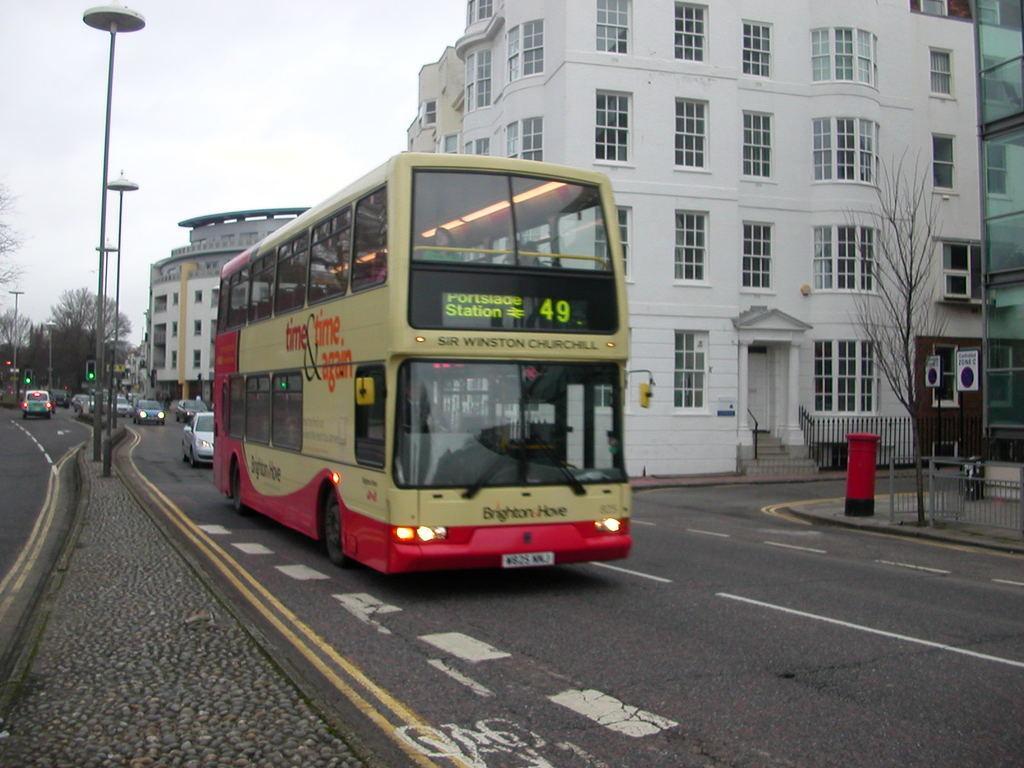In one or two sentences, can you explain what this image depicts? This picture is clicked outside. In the foreground we can see the concrete road. In the center we can see the vehicles seems to be running on the road. On the right we can see the buildings, railings, dry stems and a red color object which seems to be the post box. In the background we can see the sky, trees and we can see the traffic lights and lamp posts and some other items. 